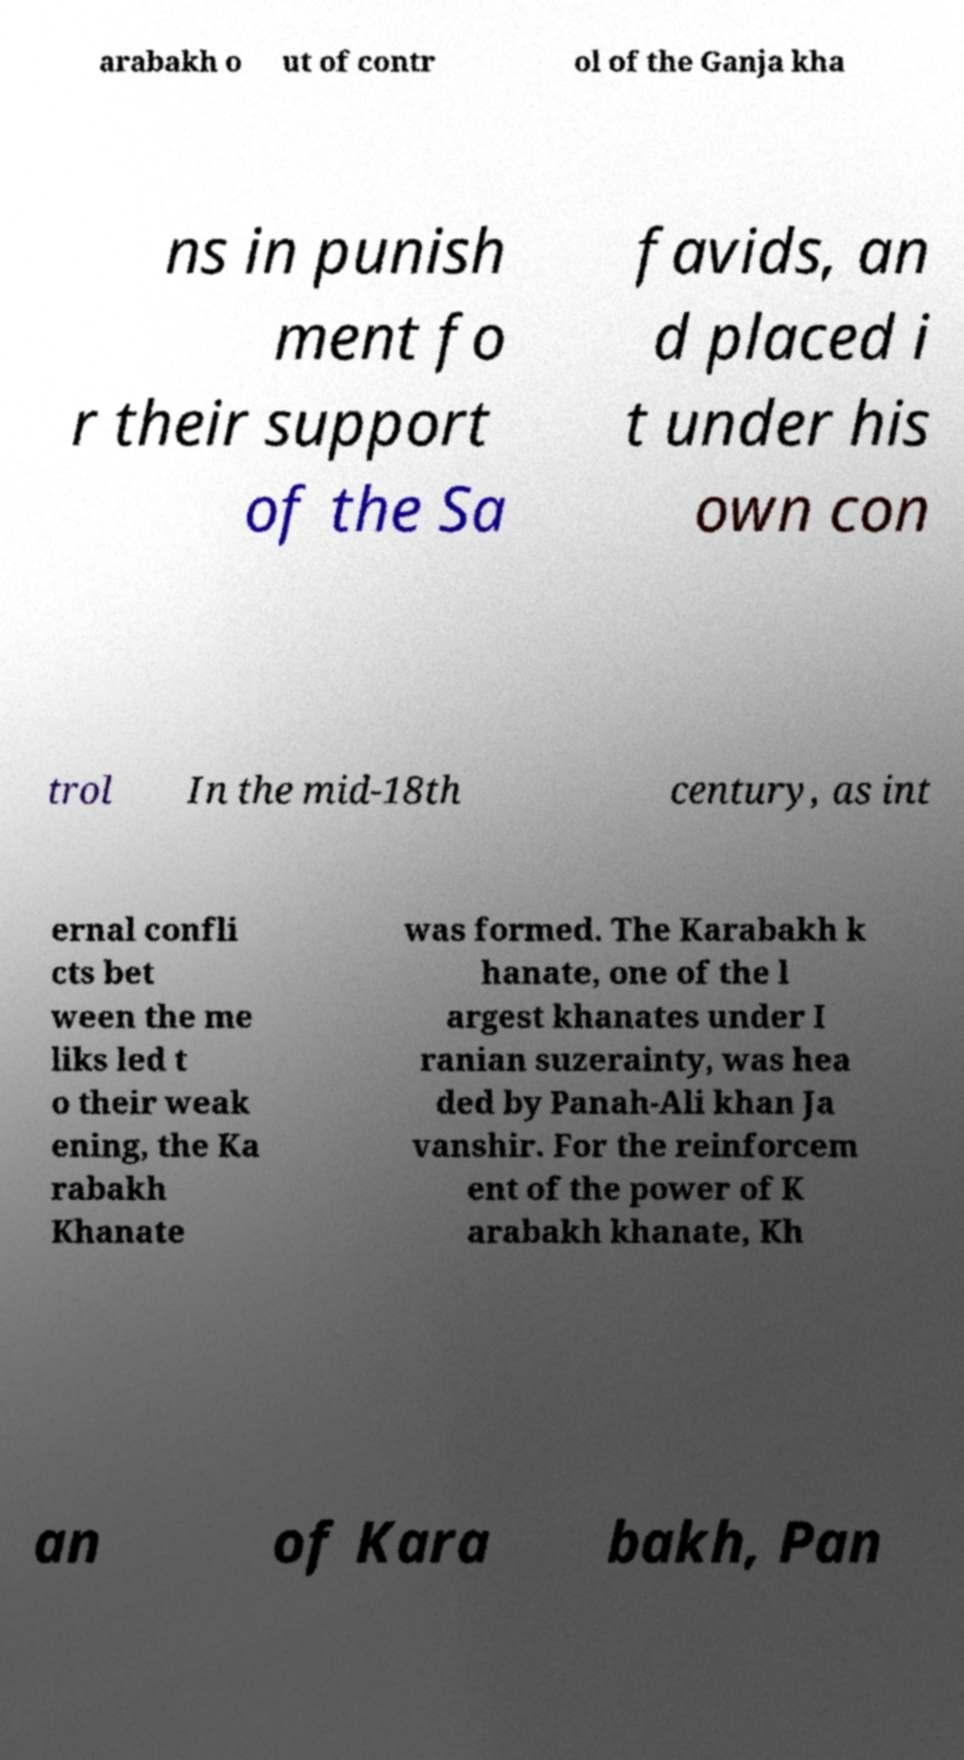Can you accurately transcribe the text from the provided image for me? arabakh o ut of contr ol of the Ganja kha ns in punish ment fo r their support of the Sa favids, an d placed i t under his own con trol In the mid-18th century, as int ernal confli cts bet ween the me liks led t o their weak ening, the Ka rabakh Khanate was formed. The Karabakh k hanate, one of the l argest khanates under I ranian suzerainty, was hea ded by Panah-Ali khan Ja vanshir. For the reinforcem ent of the power of K arabakh khanate, Kh an of Kara bakh, Pan 